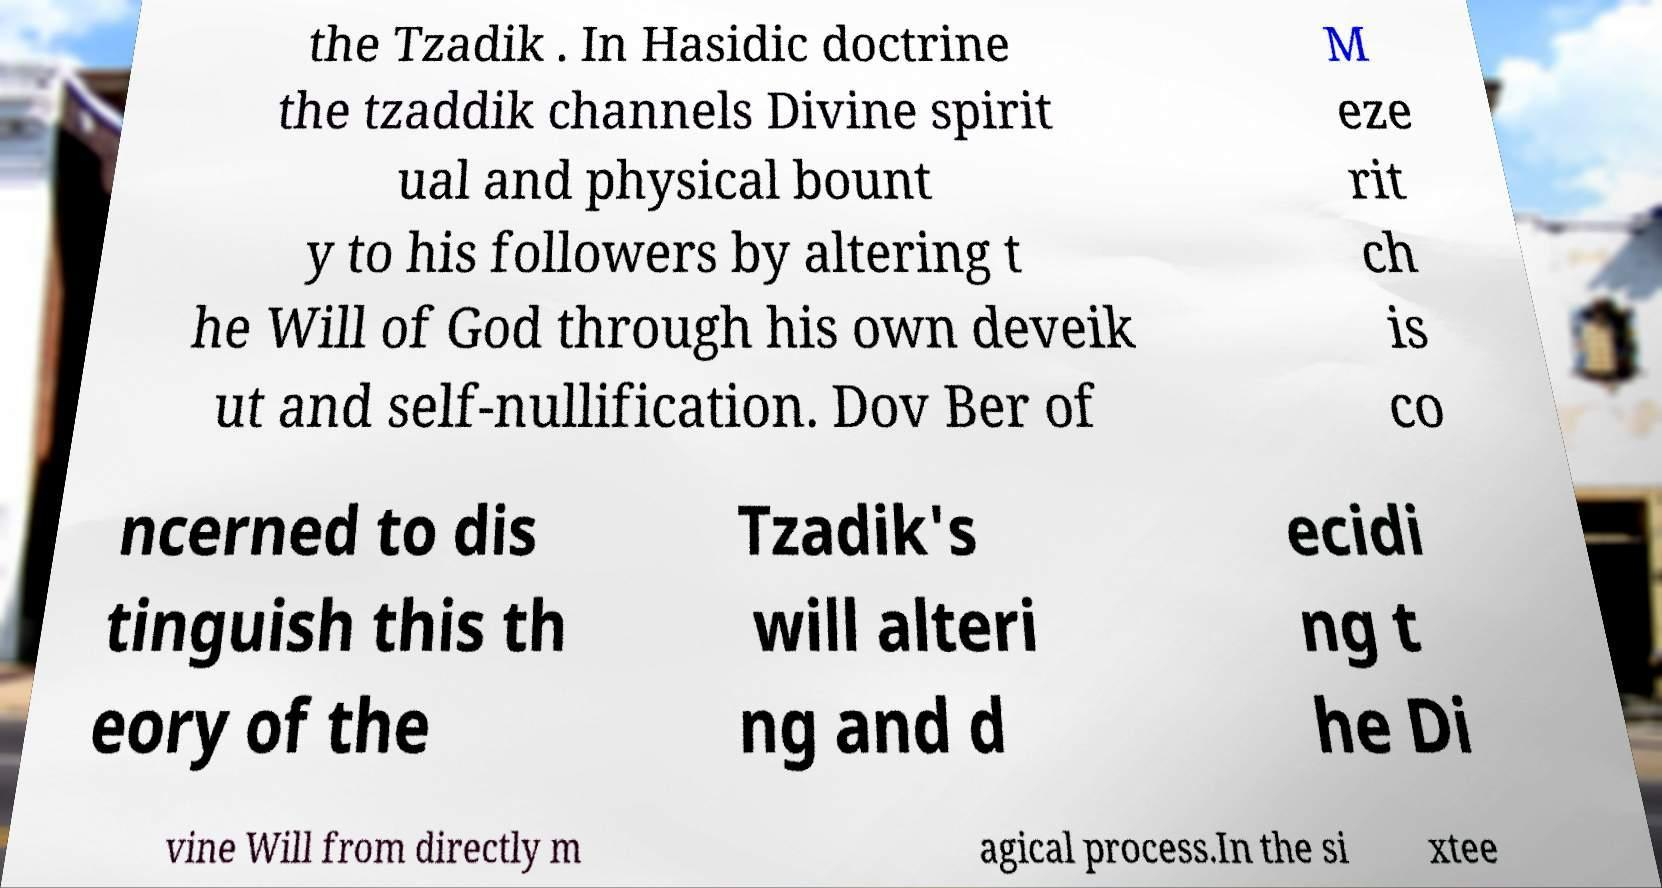I need the written content from this picture converted into text. Can you do that? the Tzadik . In Hasidic doctrine the tzaddik channels Divine spirit ual and physical bount y to his followers by altering t he Will of God through his own deveik ut and self-nullification. Dov Ber of M eze rit ch is co ncerned to dis tinguish this th eory of the Tzadik's will alteri ng and d ecidi ng t he Di vine Will from directly m agical process.In the si xtee 